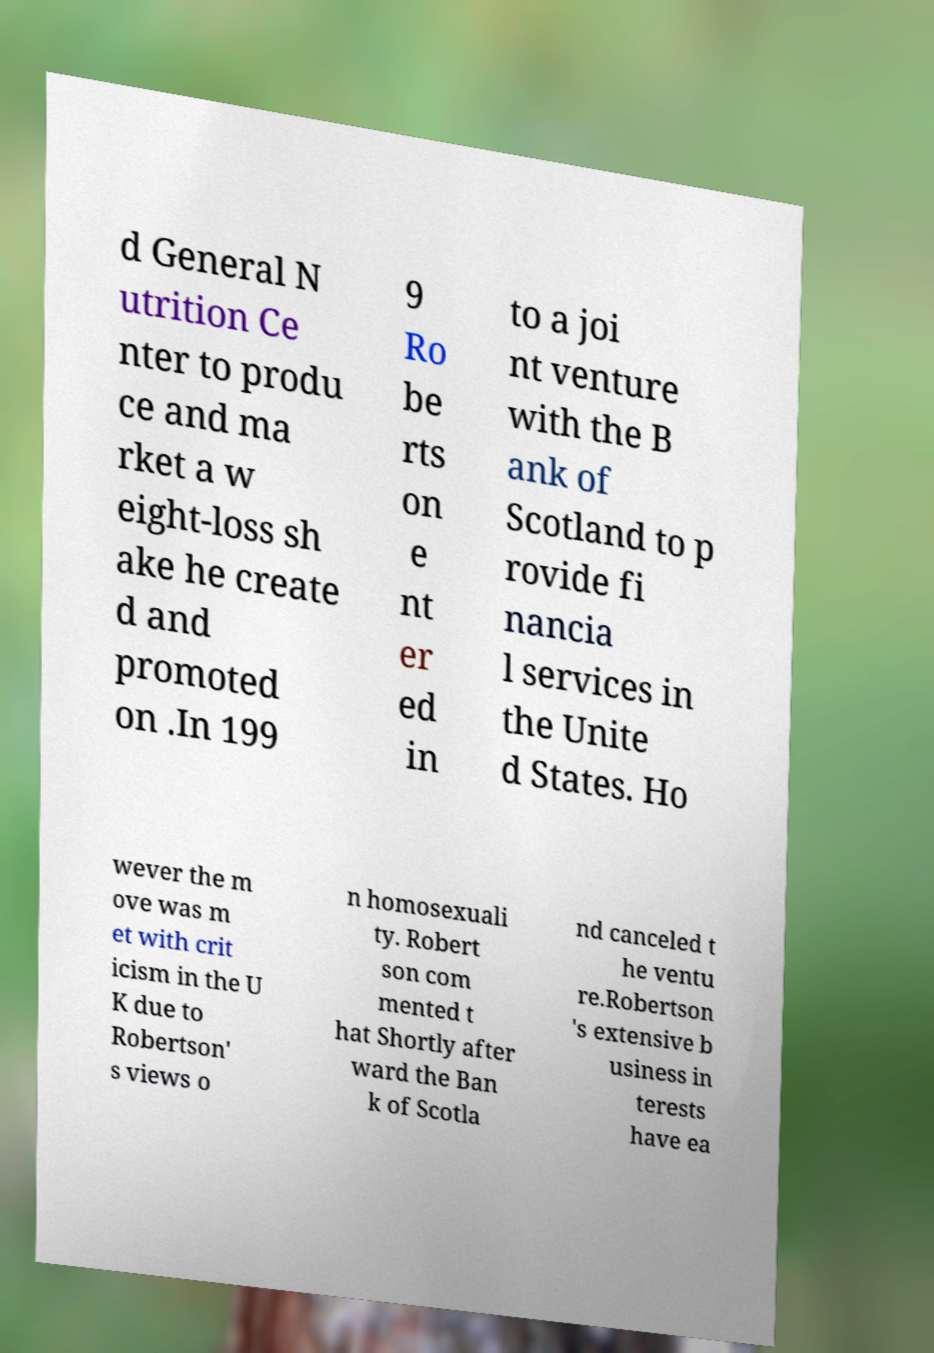I need the written content from this picture converted into text. Can you do that? d General N utrition Ce nter to produ ce and ma rket a w eight-loss sh ake he create d and promoted on .In 199 9 Ro be rts on e nt er ed in to a joi nt venture with the B ank of Scotland to p rovide fi nancia l services in the Unite d States. Ho wever the m ove was m et with crit icism in the U K due to Robertson' s views o n homosexuali ty. Robert son com mented t hat Shortly after ward the Ban k of Scotla nd canceled t he ventu re.Robertson 's extensive b usiness in terests have ea 